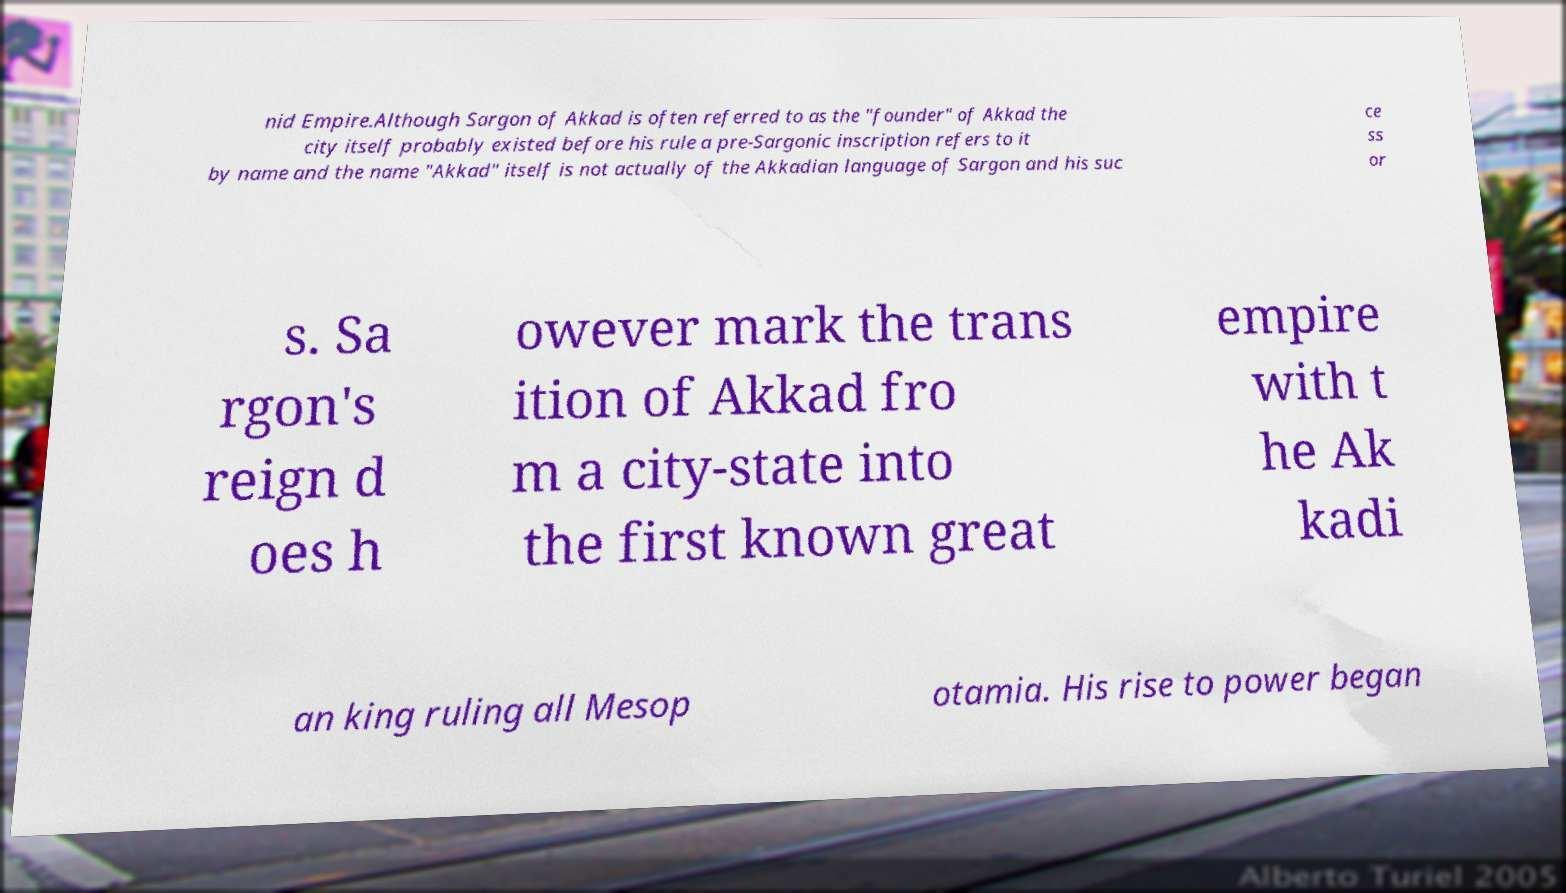Can you accurately transcribe the text from the provided image for me? nid Empire.Although Sargon of Akkad is often referred to as the "founder" of Akkad the city itself probably existed before his rule a pre-Sargonic inscription refers to it by name and the name "Akkad" itself is not actually of the Akkadian language of Sargon and his suc ce ss or s. Sa rgon's reign d oes h owever mark the trans ition of Akkad fro m a city-state into the first known great empire with t he Ak kadi an king ruling all Mesop otamia. His rise to power began 